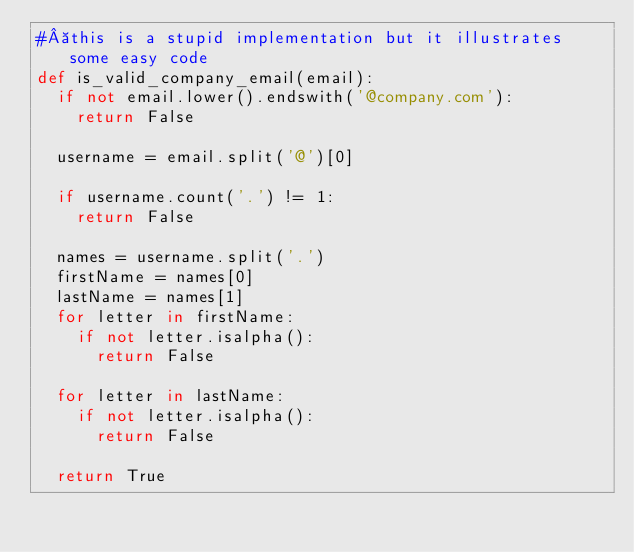Convert code to text. <code><loc_0><loc_0><loc_500><loc_500><_Python_># this is a stupid implementation but it illustrates some easy code
def is_valid_company_email(email):
  if not email.lower().endswith('@company.com'):
    return False

  username = email.split('@')[0]

  if username.count('.') != 1:
    return False

  names = username.split('.')
  firstName = names[0]
  lastName = names[1]
  for letter in firstName:
    if not letter.isalpha():
      return False

  for letter in lastName:
    if not letter.isalpha():
      return False

  return True
</code> 